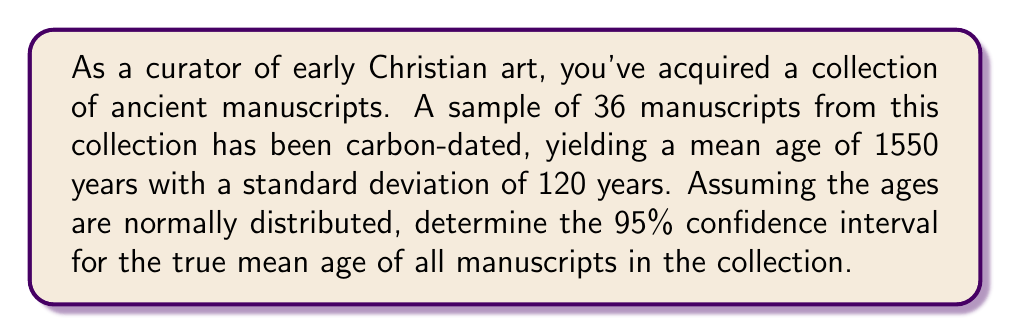Help me with this question. To find the confidence interval, we'll follow these steps:

1) The formula for a confidence interval is:

   $$\bar{x} \pm z_{\alpha/2} \cdot \frac{\sigma}{\sqrt{n}}$$

   Where:
   $\bar{x}$ is the sample mean
   $z_{\alpha/2}$ is the critical value from the standard normal distribution
   $\sigma$ is the population standard deviation
   $n$ is the sample size

2) We're given:
   $\bar{x} = 1550$ years
   $\sigma = 120$ years (we'll assume this is the population standard deviation)
   $n = 36$
   Confidence level = 95%, so $\alpha = 0.05$

3) For a 95% confidence interval, $z_{\alpha/2} = 1.96$

4) Plugging these values into the formula:

   $$1550 \pm 1.96 \cdot \frac{120}{\sqrt{36}}$$

5) Simplify:
   $$1550 \pm 1.96 \cdot \frac{120}{6} = 1550 \pm 1.96 \cdot 20 = 1550 \pm 39.2$$

6) Therefore, the confidence interval is:
   $$(1550 - 39.2, 1550 + 39.2) = (1510.8, 1589.2)$$
Answer: The 95% confidence interval for the true mean age of the manuscripts is (1510.8 years, 1589.2 years). 